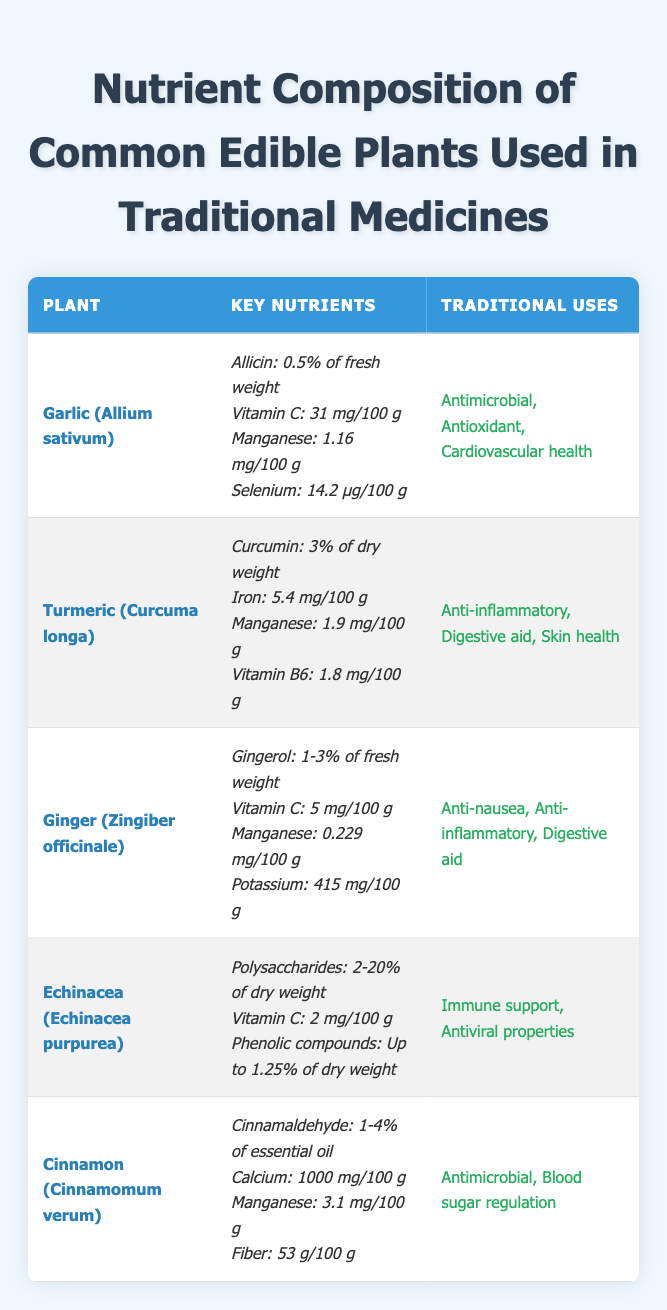What is the amount of Vitamin C in Garlic? The table lists Garlic (Allium sativum) under the plant category, where it shows that the content of Vitamin C is 31 mg/100 g.
Answer: 31 mg/100 g Which plant has the highest amount of Manganese? The table includes the amounts of Manganese for each plant: Garlic has 1.16 mg/100 g, Turmeric has 1.9 mg/100 g, Ginger has 0.229 mg/100 g, Echinacea is not listed, Cinnamon has 3.1 mg/100 g. Comparing these values, Cinnamon has the highest amount of Manganese at 3.1 mg/100 g.
Answer: Cinnamon (Cinnamomum verum) Is Ginger used for skin health? The traditional uses of Ginger (Zingiber officinale) are listed as Anti-nausea, Anti-inflammatory, and Digestive aid. Skin health is not mentioned in this list, so the answer is no.
Answer: No What is the total percentage of active compounds (Allicin, Curcumin, Gingerol, and Cinnamaldehyde) for the listed plants? The active compounds' percentages are: Allicin (0.5%), Curcumin (3%), Gingerol (average 2%), and Cinnamaldehyde (average 2.5%). Adding them up gives 0.5 + 3 + 2 + 2.5 = 8%. Therefore, the total percentage is 8%.
Answer: 8% Does Echinacea contain any Vitamins? The table lists that Echinacea (Echinacea purpurea) contains Vitamin C, which is listed as 2 mg/100 g. Therefore, the answer is yes.
Answer: Yes Which plant has both anti-inflammatory properties and contains Vitamin C? From the table, Turmeric (Curcuma longa) is used for anti-inflammatory purposes and has 31 mg/100 g of Vitamin C, and Ginger (Zingiber officinale) is also anti-inflammatory but has only 5 mg/100 g of Vitamin C. Hence, the answer is Turmeric.
Answer: Turmeric (Curcuma longa) What is the difference in Calcium content between Cinnamon and Ginger? The table shows that Cinnamon (Cinnamomum verum) has 1000 mg of Calcium per 100 g while Ginger (Zingiber officinale) has no Calcium listed, so it's 0 mg. The difference is 1000 - 0 = 1000 mg. Therefore, the difference in Calcium content is 1000 mg.
Answer: 1000 mg Which two plants are primarily used for digestive aid? The table highlights that both Ginger (Zingiber officinale) and Turmeric (Curcuma longa) are used for digestive aid purposes, therefore these two plants are the answer.
Answer: Ginger and Turmeric What is the concentration of Polysaccharides in Echinacea? The table specifies that Echinacea (Echinacea purpurea) contains Polysaccharides at 2-20% of dry weight. This indicates that while the concentration varies, the range is between 2% to 20%.
Answer: 2-20% of dry weight 